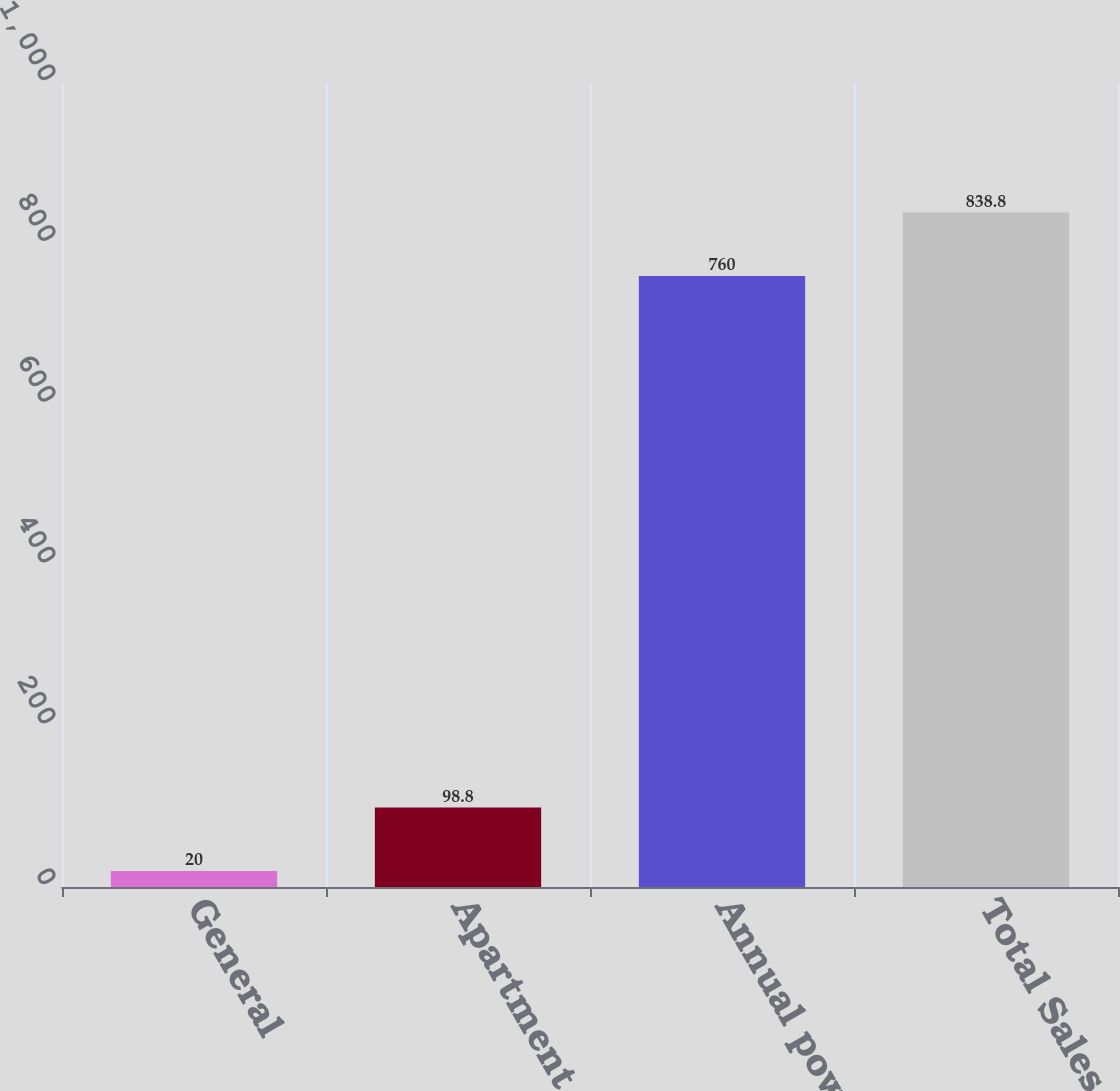<chart> <loc_0><loc_0><loc_500><loc_500><bar_chart><fcel>General<fcel>Apartment house<fcel>Annual power<fcel>Total Sales<nl><fcel>20<fcel>98.8<fcel>760<fcel>838.8<nl></chart> 